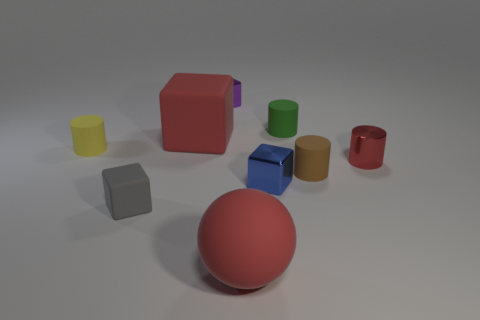What number of objects are either large brown cylinders or objects?
Make the answer very short. 9. There is a big thing that is in front of the small object to the left of the gray cube; what is its material?
Your answer should be compact. Rubber. Are there any tiny metallic things of the same color as the sphere?
Provide a succinct answer. Yes. What is the color of the metal cylinder that is the same size as the yellow rubber object?
Keep it short and to the point. Red. What material is the small cylinder on the left side of the matte block in front of the matte object on the left side of the gray matte block?
Make the answer very short. Rubber. Do the ball and the small matte cylinder that is in front of the yellow matte cylinder have the same color?
Provide a short and direct response. No. What number of things are matte cylinders on the right side of the tiny green thing or small blocks in front of the green matte thing?
Give a very brief answer. 3. The large rubber object that is right of the red rubber thing behind the small gray matte object is what shape?
Ensure brevity in your answer.  Sphere. Are there any purple objects that have the same material as the tiny green cylinder?
Give a very brief answer. No. The other small metal thing that is the same shape as the small blue object is what color?
Make the answer very short. Purple. 